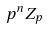Convert formula to latex. <formula><loc_0><loc_0><loc_500><loc_500>p ^ { n } Z _ { p }</formula> 